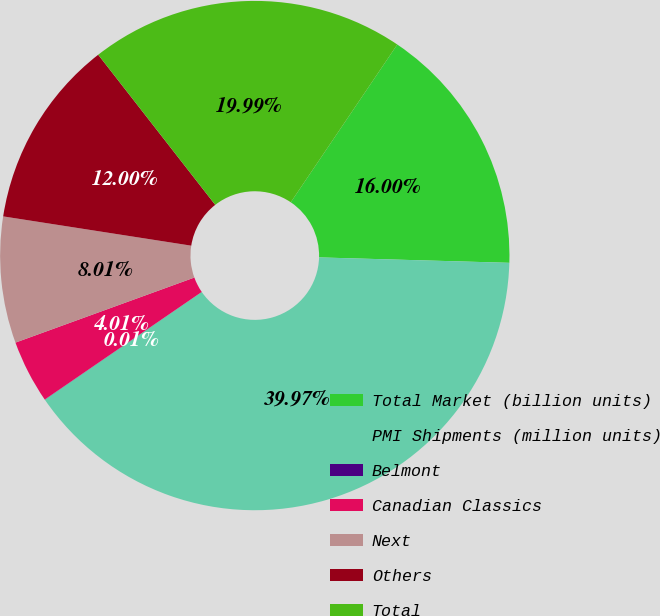<chart> <loc_0><loc_0><loc_500><loc_500><pie_chart><fcel>Total Market (billion units)<fcel>PMI Shipments (million units)<fcel>Belmont<fcel>Canadian Classics<fcel>Next<fcel>Others<fcel>Total<nl><fcel>16.0%<fcel>39.97%<fcel>0.01%<fcel>4.01%<fcel>8.01%<fcel>12.0%<fcel>19.99%<nl></chart> 